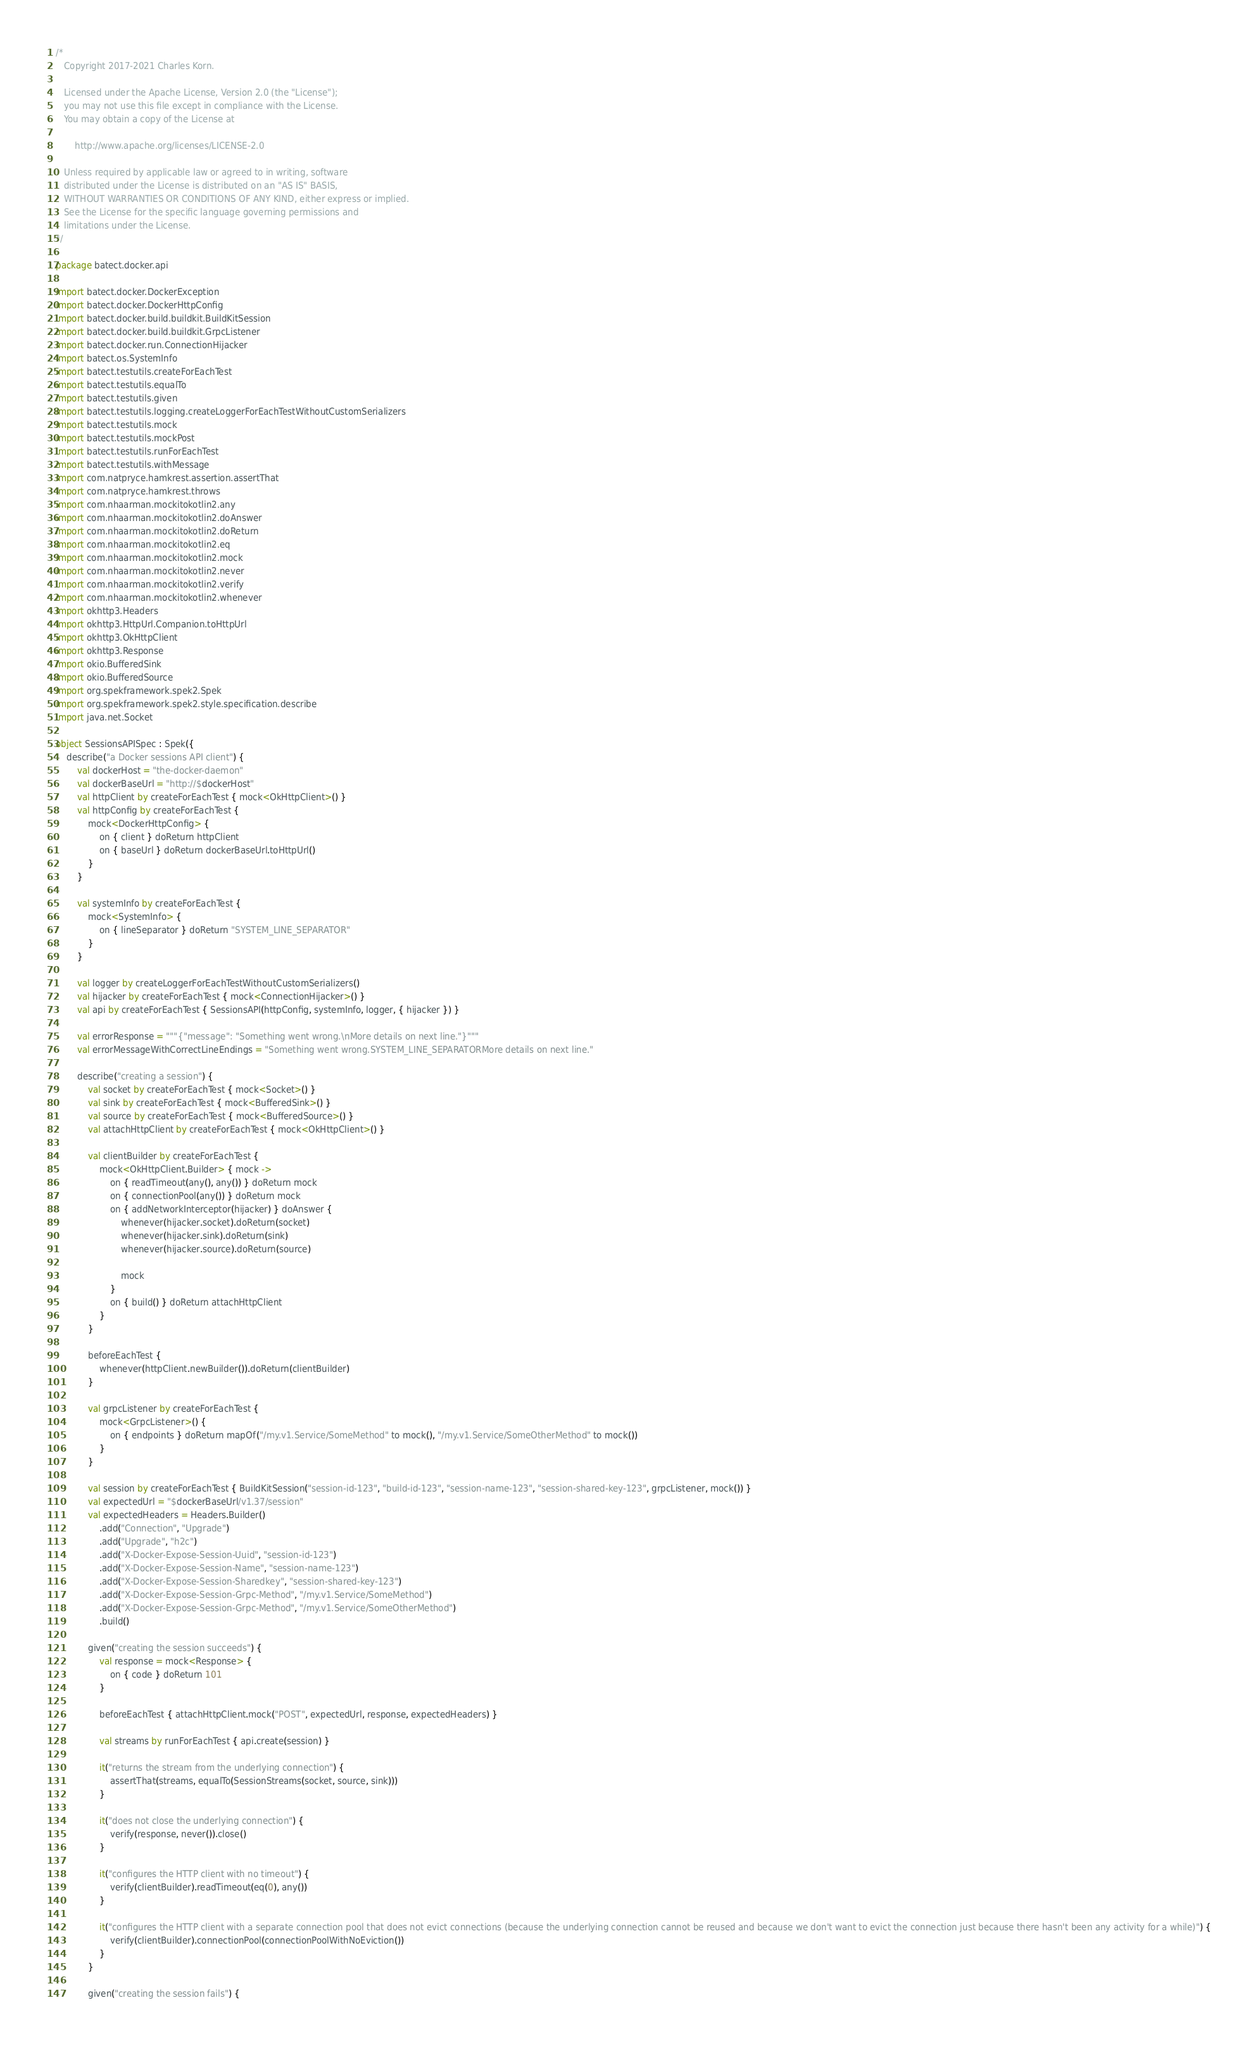<code> <loc_0><loc_0><loc_500><loc_500><_Kotlin_>/*
   Copyright 2017-2021 Charles Korn.

   Licensed under the Apache License, Version 2.0 (the "License");
   you may not use this file except in compliance with the License.
   You may obtain a copy of the License at

       http://www.apache.org/licenses/LICENSE-2.0

   Unless required by applicable law or agreed to in writing, software
   distributed under the License is distributed on an "AS IS" BASIS,
   WITHOUT WARRANTIES OR CONDITIONS OF ANY KIND, either express or implied.
   See the License for the specific language governing permissions and
   limitations under the License.
*/

package batect.docker.api

import batect.docker.DockerException
import batect.docker.DockerHttpConfig
import batect.docker.build.buildkit.BuildKitSession
import batect.docker.build.buildkit.GrpcListener
import batect.docker.run.ConnectionHijacker
import batect.os.SystemInfo
import batect.testutils.createForEachTest
import batect.testutils.equalTo
import batect.testutils.given
import batect.testutils.logging.createLoggerForEachTestWithoutCustomSerializers
import batect.testutils.mock
import batect.testutils.mockPost
import batect.testutils.runForEachTest
import batect.testutils.withMessage
import com.natpryce.hamkrest.assertion.assertThat
import com.natpryce.hamkrest.throws
import com.nhaarman.mockitokotlin2.any
import com.nhaarman.mockitokotlin2.doAnswer
import com.nhaarman.mockitokotlin2.doReturn
import com.nhaarman.mockitokotlin2.eq
import com.nhaarman.mockitokotlin2.mock
import com.nhaarman.mockitokotlin2.never
import com.nhaarman.mockitokotlin2.verify
import com.nhaarman.mockitokotlin2.whenever
import okhttp3.Headers
import okhttp3.HttpUrl.Companion.toHttpUrl
import okhttp3.OkHttpClient
import okhttp3.Response
import okio.BufferedSink
import okio.BufferedSource
import org.spekframework.spek2.Spek
import org.spekframework.spek2.style.specification.describe
import java.net.Socket

object SessionsAPISpec : Spek({
    describe("a Docker sessions API client") {
        val dockerHost = "the-docker-daemon"
        val dockerBaseUrl = "http://$dockerHost"
        val httpClient by createForEachTest { mock<OkHttpClient>() }
        val httpConfig by createForEachTest {
            mock<DockerHttpConfig> {
                on { client } doReturn httpClient
                on { baseUrl } doReturn dockerBaseUrl.toHttpUrl()
            }
        }

        val systemInfo by createForEachTest {
            mock<SystemInfo> {
                on { lineSeparator } doReturn "SYSTEM_LINE_SEPARATOR"
            }
        }

        val logger by createLoggerForEachTestWithoutCustomSerializers()
        val hijacker by createForEachTest { mock<ConnectionHijacker>() }
        val api by createForEachTest { SessionsAPI(httpConfig, systemInfo, logger, { hijacker }) }

        val errorResponse = """{"message": "Something went wrong.\nMore details on next line."}"""
        val errorMessageWithCorrectLineEndings = "Something went wrong.SYSTEM_LINE_SEPARATORMore details on next line."

        describe("creating a session") {
            val socket by createForEachTest { mock<Socket>() }
            val sink by createForEachTest { mock<BufferedSink>() }
            val source by createForEachTest { mock<BufferedSource>() }
            val attachHttpClient by createForEachTest { mock<OkHttpClient>() }

            val clientBuilder by createForEachTest {
                mock<OkHttpClient.Builder> { mock ->
                    on { readTimeout(any(), any()) } doReturn mock
                    on { connectionPool(any()) } doReturn mock
                    on { addNetworkInterceptor(hijacker) } doAnswer {
                        whenever(hijacker.socket).doReturn(socket)
                        whenever(hijacker.sink).doReturn(sink)
                        whenever(hijacker.source).doReturn(source)

                        mock
                    }
                    on { build() } doReturn attachHttpClient
                }
            }

            beforeEachTest {
                whenever(httpClient.newBuilder()).doReturn(clientBuilder)
            }

            val grpcListener by createForEachTest {
                mock<GrpcListener>() {
                    on { endpoints } doReturn mapOf("/my.v1.Service/SomeMethod" to mock(), "/my.v1.Service/SomeOtherMethod" to mock())
                }
            }

            val session by createForEachTest { BuildKitSession("session-id-123", "build-id-123", "session-name-123", "session-shared-key-123", grpcListener, mock()) }
            val expectedUrl = "$dockerBaseUrl/v1.37/session"
            val expectedHeaders = Headers.Builder()
                .add("Connection", "Upgrade")
                .add("Upgrade", "h2c")
                .add("X-Docker-Expose-Session-Uuid", "session-id-123")
                .add("X-Docker-Expose-Session-Name", "session-name-123")
                .add("X-Docker-Expose-Session-Sharedkey", "session-shared-key-123")
                .add("X-Docker-Expose-Session-Grpc-Method", "/my.v1.Service/SomeMethod")
                .add("X-Docker-Expose-Session-Grpc-Method", "/my.v1.Service/SomeOtherMethod")
                .build()

            given("creating the session succeeds") {
                val response = mock<Response> {
                    on { code } doReturn 101
                }

                beforeEachTest { attachHttpClient.mock("POST", expectedUrl, response, expectedHeaders) }

                val streams by runForEachTest { api.create(session) }

                it("returns the stream from the underlying connection") {
                    assertThat(streams, equalTo(SessionStreams(socket, source, sink)))
                }

                it("does not close the underlying connection") {
                    verify(response, never()).close()
                }

                it("configures the HTTP client with no timeout") {
                    verify(clientBuilder).readTimeout(eq(0), any())
                }

                it("configures the HTTP client with a separate connection pool that does not evict connections (because the underlying connection cannot be reused and because we don't want to evict the connection just because there hasn't been any activity for a while)") {
                    verify(clientBuilder).connectionPool(connectionPoolWithNoEviction())
                }
            }

            given("creating the session fails") {</code> 